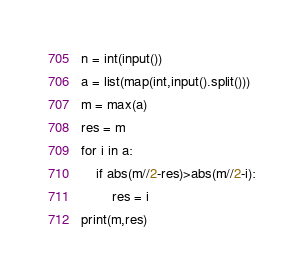<code> <loc_0><loc_0><loc_500><loc_500><_Python_>n = int(input())
a = list(map(int,input().split()))
m = max(a)
res = m
for i in a:
    if abs(m//2-res)>abs(m//2-i):
        res = i
print(m,res)
</code> 